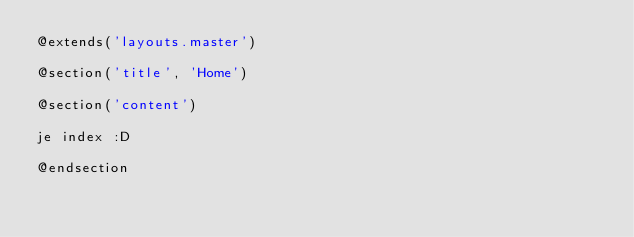Convert code to text. <code><loc_0><loc_0><loc_500><loc_500><_PHP_>@extends('layouts.master')

@section('title', 'Home')

@section('content')

je index :D

@endsection</code> 